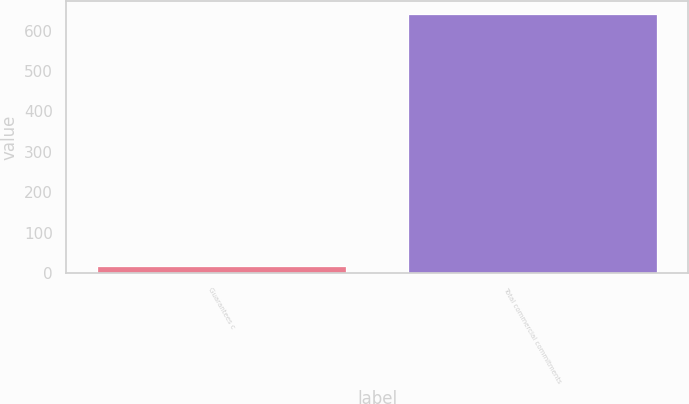Convert chart. <chart><loc_0><loc_0><loc_500><loc_500><bar_chart><fcel>Guarantees c<fcel>Total commercial commitments<nl><fcel>18<fcel>642<nl></chart> 